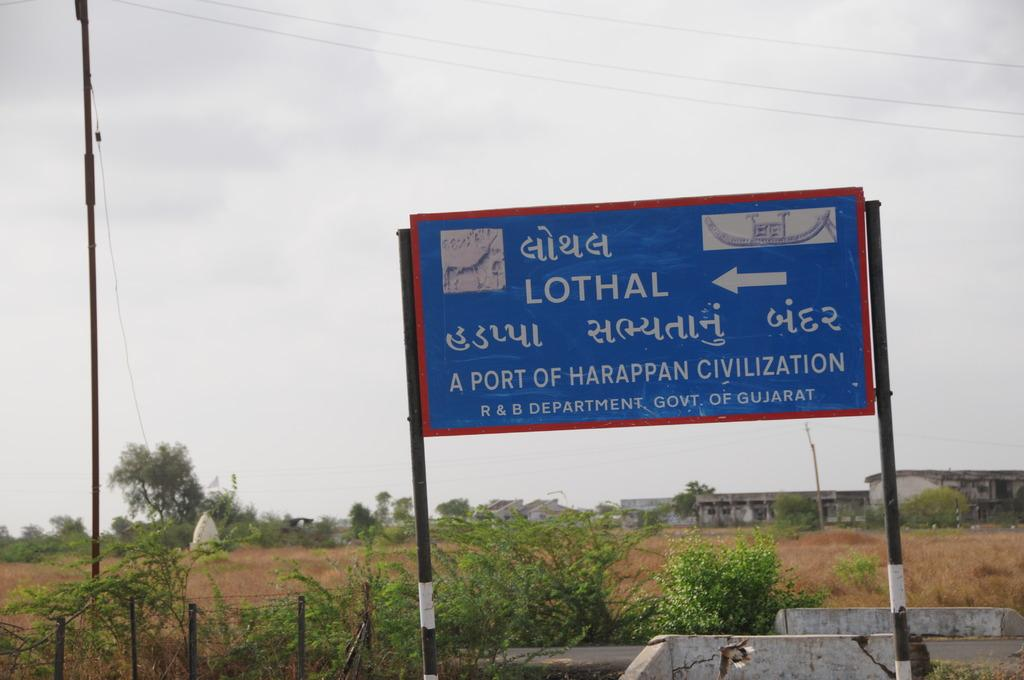<image>
Describe the image concisely. the word lothal is on a blue sign 